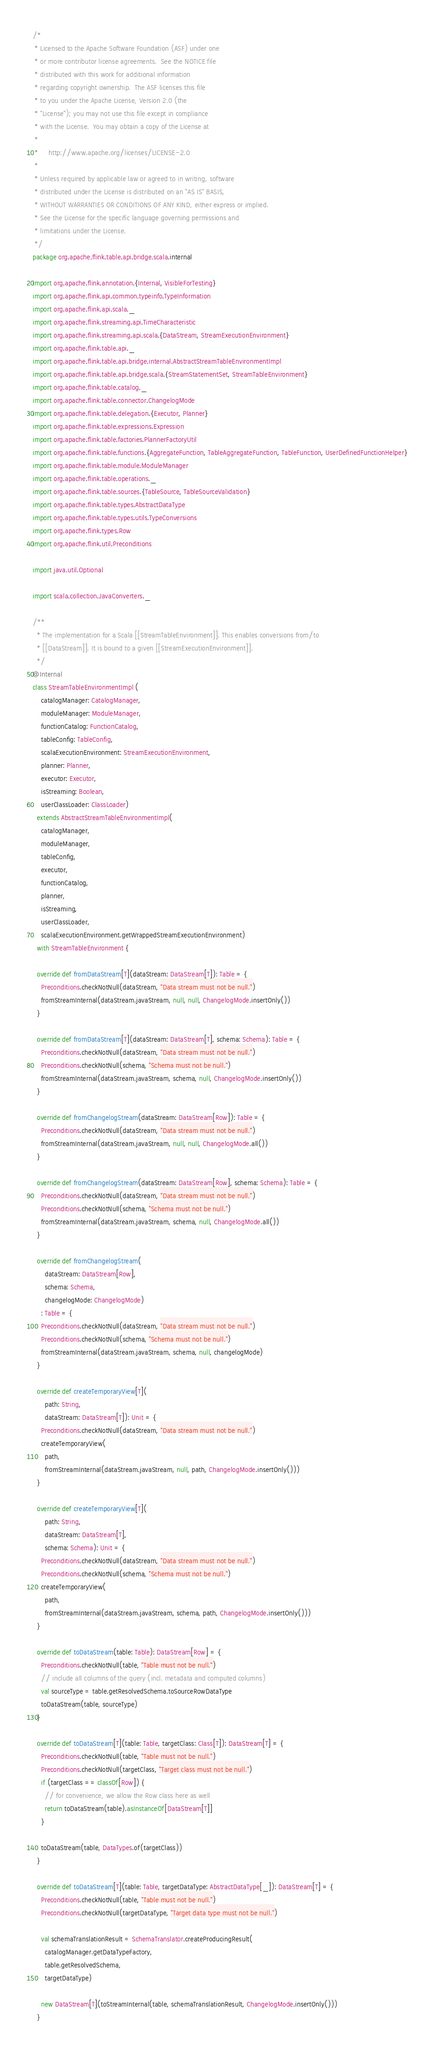<code> <loc_0><loc_0><loc_500><loc_500><_Scala_>/*
 * Licensed to the Apache Software Foundation (ASF) under one
 * or more contributor license agreements.  See the NOTICE file
 * distributed with this work for additional information
 * regarding copyright ownership.  The ASF licenses this file
 * to you under the Apache License, Version 2.0 (the
 * "License"); you may not use this file except in compliance
 * with the License.  You may obtain a copy of the License at
 *
 *     http://www.apache.org/licenses/LICENSE-2.0
 *
 * Unless required by applicable law or agreed to in writing, software
 * distributed under the License is distributed on an "AS IS" BASIS,
 * WITHOUT WARRANTIES OR CONDITIONS OF ANY KIND, either express or implied.
 * See the License for the specific language governing permissions and
 * limitations under the License.
 */
package org.apache.flink.table.api.bridge.scala.internal

import org.apache.flink.annotation.{Internal, VisibleForTesting}
import org.apache.flink.api.common.typeinfo.TypeInformation
import org.apache.flink.api.scala._
import org.apache.flink.streaming.api.TimeCharacteristic
import org.apache.flink.streaming.api.scala.{DataStream, StreamExecutionEnvironment}
import org.apache.flink.table.api._
import org.apache.flink.table.api.bridge.internal.AbstractStreamTableEnvironmentImpl
import org.apache.flink.table.api.bridge.scala.{StreamStatementSet, StreamTableEnvironment}
import org.apache.flink.table.catalog._
import org.apache.flink.table.connector.ChangelogMode
import org.apache.flink.table.delegation.{Executor, Planner}
import org.apache.flink.table.expressions.Expression
import org.apache.flink.table.factories.PlannerFactoryUtil
import org.apache.flink.table.functions.{AggregateFunction, TableAggregateFunction, TableFunction, UserDefinedFunctionHelper}
import org.apache.flink.table.module.ModuleManager
import org.apache.flink.table.operations._
import org.apache.flink.table.sources.{TableSource, TableSourceValidation}
import org.apache.flink.table.types.AbstractDataType
import org.apache.flink.table.types.utils.TypeConversions
import org.apache.flink.types.Row
import org.apache.flink.util.Preconditions

import java.util.Optional

import scala.collection.JavaConverters._

/**
  * The implementation for a Scala [[StreamTableEnvironment]]. This enables conversions from/to
  * [[DataStream]]. It is bound to a given [[StreamExecutionEnvironment]].
  */
@Internal
class StreamTableEnvironmentImpl (
    catalogManager: CatalogManager,
    moduleManager: ModuleManager,
    functionCatalog: FunctionCatalog,
    tableConfig: TableConfig,
    scalaExecutionEnvironment: StreamExecutionEnvironment,
    planner: Planner,
    executor: Executor,
    isStreaming: Boolean,
    userClassLoader: ClassLoader)
  extends AbstractStreamTableEnvironmentImpl(
    catalogManager,
    moduleManager,
    tableConfig,
    executor,
    functionCatalog,
    planner,
    isStreaming,
    userClassLoader,
    scalaExecutionEnvironment.getWrappedStreamExecutionEnvironment)
  with StreamTableEnvironment {

  override def fromDataStream[T](dataStream: DataStream[T]): Table = {
    Preconditions.checkNotNull(dataStream, "Data stream must not be null.")
    fromStreamInternal(dataStream.javaStream, null, null, ChangelogMode.insertOnly())
  }

  override def fromDataStream[T](dataStream: DataStream[T], schema: Schema): Table = {
    Preconditions.checkNotNull(dataStream, "Data stream must not be null.")
    Preconditions.checkNotNull(schema, "Schema must not be null.")
    fromStreamInternal(dataStream.javaStream, schema, null, ChangelogMode.insertOnly())
  }

  override def fromChangelogStream(dataStream: DataStream[Row]): Table = {
    Preconditions.checkNotNull(dataStream, "Data stream must not be null.")
    fromStreamInternal(dataStream.javaStream, null, null, ChangelogMode.all())
  }

  override def fromChangelogStream(dataStream: DataStream[Row], schema: Schema): Table = {
    Preconditions.checkNotNull(dataStream, "Data stream must not be null.")
    Preconditions.checkNotNull(schema, "Schema must not be null.")
    fromStreamInternal(dataStream.javaStream, schema, null, ChangelogMode.all())
  }

  override def fromChangelogStream(
      dataStream: DataStream[Row],
      schema: Schema,
      changelogMode: ChangelogMode)
    : Table = {
    Preconditions.checkNotNull(dataStream, "Data stream must not be null.")
    Preconditions.checkNotNull(schema, "Schema must not be null.")
    fromStreamInternal(dataStream.javaStream, schema, null, changelogMode)
  }

  override def createTemporaryView[T](
      path: String,
      dataStream: DataStream[T]): Unit = {
    Preconditions.checkNotNull(dataStream, "Data stream must not be null.")
    createTemporaryView(
      path,
      fromStreamInternal(dataStream.javaStream, null, path, ChangelogMode.insertOnly()))
  }

  override def createTemporaryView[T](
      path: String,
      dataStream: DataStream[T],
      schema: Schema): Unit = {
    Preconditions.checkNotNull(dataStream, "Data stream must not be null.")
    Preconditions.checkNotNull(schema, "Schema must not be null.")
    createTemporaryView(
      path,
      fromStreamInternal(dataStream.javaStream, schema, path, ChangelogMode.insertOnly()))
  }

  override def toDataStream(table: Table): DataStream[Row] = {
    Preconditions.checkNotNull(table, "Table must not be null.")
    // include all columns of the query (incl. metadata and computed columns)
    val sourceType = table.getResolvedSchema.toSourceRowDataType
    toDataStream(table, sourceType)
  }

  override def toDataStream[T](table: Table, targetClass: Class[T]): DataStream[T] = {
    Preconditions.checkNotNull(table, "Table must not be null.")
    Preconditions.checkNotNull(targetClass, "Target class must not be null.")
    if (targetClass == classOf[Row]) {
      // for convenience, we allow the Row class here as well
      return toDataStream(table).asInstanceOf[DataStream[T]]
    }

    toDataStream(table, DataTypes.of(targetClass))
  }

  override def toDataStream[T](table: Table, targetDataType: AbstractDataType[_]): DataStream[T] = {
    Preconditions.checkNotNull(table, "Table must not be null.")
    Preconditions.checkNotNull(targetDataType, "Target data type must not be null.")

    val schemaTranslationResult = SchemaTranslator.createProducingResult(
      catalogManager.getDataTypeFactory,
      table.getResolvedSchema,
      targetDataType)

    new DataStream[T](toStreamInternal(table, schemaTranslationResult, ChangelogMode.insertOnly()))
  }
</code> 